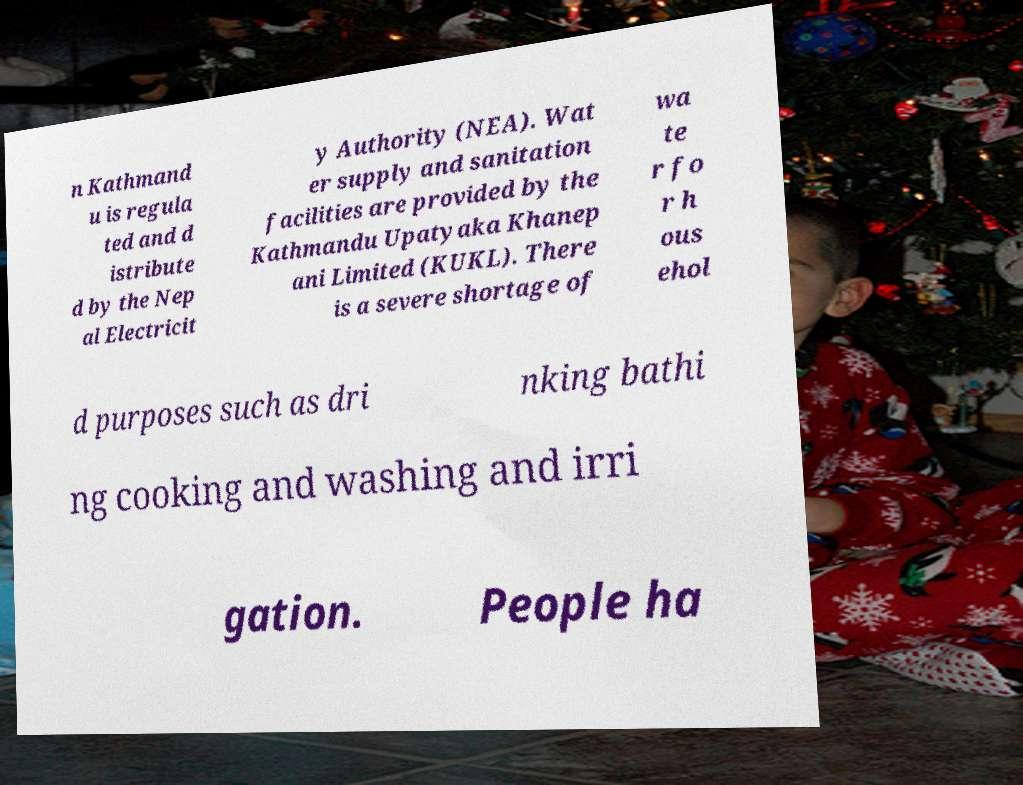Can you accurately transcribe the text from the provided image for me? n Kathmand u is regula ted and d istribute d by the Nep al Electricit y Authority (NEA). Wat er supply and sanitation facilities are provided by the Kathmandu Upatyaka Khanep ani Limited (KUKL). There is a severe shortage of wa te r fo r h ous ehol d purposes such as dri nking bathi ng cooking and washing and irri gation. People ha 